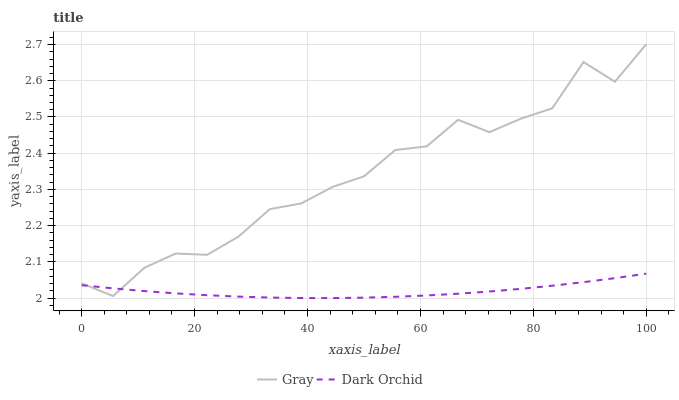Does Dark Orchid have the minimum area under the curve?
Answer yes or no. Yes. Does Gray have the maximum area under the curve?
Answer yes or no. Yes. Does Dark Orchid have the maximum area under the curve?
Answer yes or no. No. Is Dark Orchid the smoothest?
Answer yes or no. Yes. Is Gray the roughest?
Answer yes or no. Yes. Is Dark Orchid the roughest?
Answer yes or no. No. Does Dark Orchid have the lowest value?
Answer yes or no. Yes. Does Gray have the highest value?
Answer yes or no. Yes. Does Dark Orchid have the highest value?
Answer yes or no. No. Does Gray intersect Dark Orchid?
Answer yes or no. Yes. Is Gray less than Dark Orchid?
Answer yes or no. No. Is Gray greater than Dark Orchid?
Answer yes or no. No. 